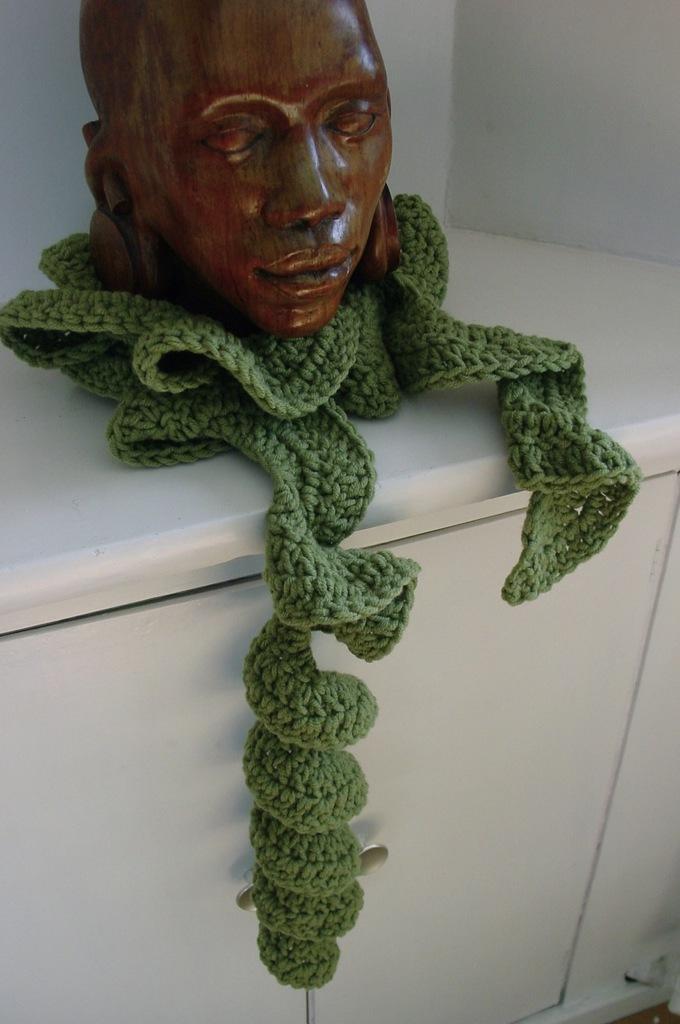Can you describe this image briefly? In this image we can see a statue of person kept on a cloth which is placed on a cupboard. 